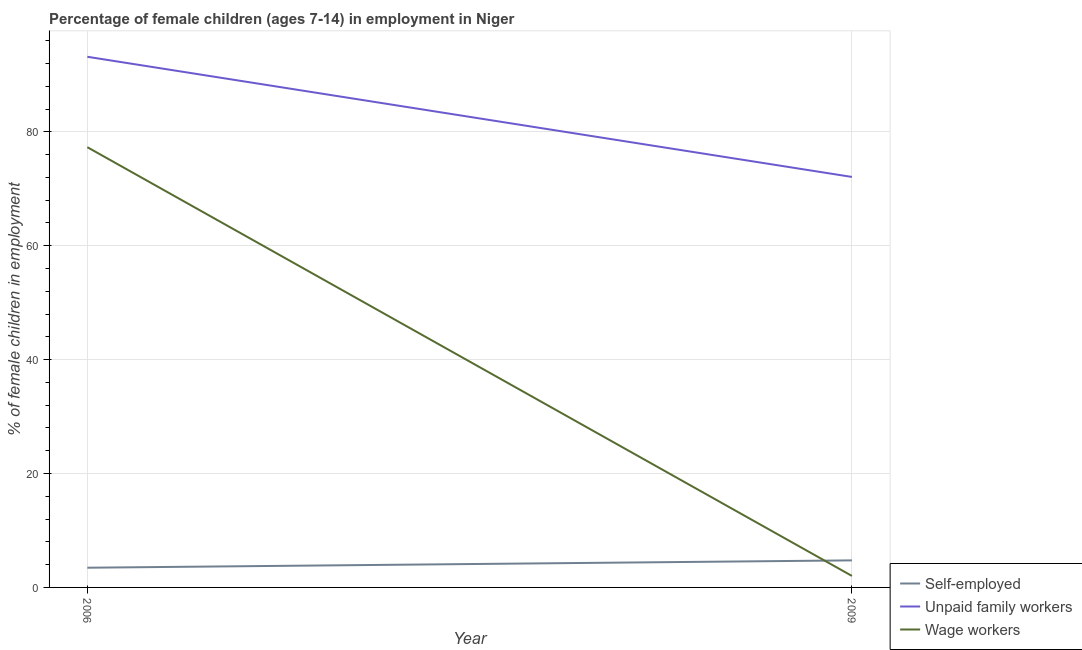What is the percentage of children employed as wage workers in 2006?
Offer a very short reply. 77.3. Across all years, what is the maximum percentage of self employed children?
Your answer should be very brief. 4.75. Across all years, what is the minimum percentage of self employed children?
Offer a very short reply. 3.46. In which year was the percentage of self employed children minimum?
Give a very brief answer. 2006. What is the total percentage of children employed as wage workers in the graph?
Your answer should be compact. 79.32. What is the difference between the percentage of children employed as wage workers in 2006 and that in 2009?
Ensure brevity in your answer.  75.28. What is the difference between the percentage of children employed as unpaid family workers in 2006 and the percentage of self employed children in 2009?
Your answer should be very brief. 88.43. What is the average percentage of self employed children per year?
Offer a very short reply. 4.11. In the year 2006, what is the difference between the percentage of self employed children and percentage of children employed as unpaid family workers?
Give a very brief answer. -89.72. What is the ratio of the percentage of self employed children in 2006 to that in 2009?
Keep it short and to the point. 0.73. Is the percentage of children employed as unpaid family workers in 2006 less than that in 2009?
Offer a terse response. No. Is it the case that in every year, the sum of the percentage of self employed children and percentage of children employed as unpaid family workers is greater than the percentage of children employed as wage workers?
Your response must be concise. Yes. Is the percentage of self employed children strictly greater than the percentage of children employed as unpaid family workers over the years?
Offer a terse response. No. What is the difference between two consecutive major ticks on the Y-axis?
Offer a terse response. 20. Are the values on the major ticks of Y-axis written in scientific E-notation?
Provide a succinct answer. No. How are the legend labels stacked?
Keep it short and to the point. Vertical. What is the title of the graph?
Give a very brief answer. Percentage of female children (ages 7-14) in employment in Niger. Does "Secondary" appear as one of the legend labels in the graph?
Give a very brief answer. No. What is the label or title of the Y-axis?
Your response must be concise. % of female children in employment. What is the % of female children in employment in Self-employed in 2006?
Keep it short and to the point. 3.46. What is the % of female children in employment in Unpaid family workers in 2006?
Give a very brief answer. 93.18. What is the % of female children in employment in Wage workers in 2006?
Provide a short and direct response. 77.3. What is the % of female children in employment of Self-employed in 2009?
Your answer should be compact. 4.75. What is the % of female children in employment in Unpaid family workers in 2009?
Make the answer very short. 72.08. What is the % of female children in employment in Wage workers in 2009?
Make the answer very short. 2.02. Across all years, what is the maximum % of female children in employment of Self-employed?
Your response must be concise. 4.75. Across all years, what is the maximum % of female children in employment in Unpaid family workers?
Offer a very short reply. 93.18. Across all years, what is the maximum % of female children in employment in Wage workers?
Your answer should be compact. 77.3. Across all years, what is the minimum % of female children in employment of Self-employed?
Give a very brief answer. 3.46. Across all years, what is the minimum % of female children in employment of Unpaid family workers?
Offer a very short reply. 72.08. Across all years, what is the minimum % of female children in employment of Wage workers?
Give a very brief answer. 2.02. What is the total % of female children in employment in Self-employed in the graph?
Your answer should be very brief. 8.21. What is the total % of female children in employment in Unpaid family workers in the graph?
Give a very brief answer. 165.26. What is the total % of female children in employment in Wage workers in the graph?
Provide a succinct answer. 79.32. What is the difference between the % of female children in employment of Self-employed in 2006 and that in 2009?
Provide a short and direct response. -1.29. What is the difference between the % of female children in employment of Unpaid family workers in 2006 and that in 2009?
Provide a succinct answer. 21.1. What is the difference between the % of female children in employment of Wage workers in 2006 and that in 2009?
Your answer should be very brief. 75.28. What is the difference between the % of female children in employment in Self-employed in 2006 and the % of female children in employment in Unpaid family workers in 2009?
Your response must be concise. -68.62. What is the difference between the % of female children in employment in Self-employed in 2006 and the % of female children in employment in Wage workers in 2009?
Your response must be concise. 1.44. What is the difference between the % of female children in employment in Unpaid family workers in 2006 and the % of female children in employment in Wage workers in 2009?
Your response must be concise. 91.16. What is the average % of female children in employment in Self-employed per year?
Your answer should be compact. 4.11. What is the average % of female children in employment of Unpaid family workers per year?
Your answer should be compact. 82.63. What is the average % of female children in employment in Wage workers per year?
Keep it short and to the point. 39.66. In the year 2006, what is the difference between the % of female children in employment in Self-employed and % of female children in employment in Unpaid family workers?
Offer a terse response. -89.72. In the year 2006, what is the difference between the % of female children in employment of Self-employed and % of female children in employment of Wage workers?
Give a very brief answer. -73.84. In the year 2006, what is the difference between the % of female children in employment of Unpaid family workers and % of female children in employment of Wage workers?
Make the answer very short. 15.88. In the year 2009, what is the difference between the % of female children in employment in Self-employed and % of female children in employment in Unpaid family workers?
Offer a terse response. -67.33. In the year 2009, what is the difference between the % of female children in employment of Self-employed and % of female children in employment of Wage workers?
Your response must be concise. 2.73. In the year 2009, what is the difference between the % of female children in employment in Unpaid family workers and % of female children in employment in Wage workers?
Provide a short and direct response. 70.06. What is the ratio of the % of female children in employment in Self-employed in 2006 to that in 2009?
Offer a very short reply. 0.73. What is the ratio of the % of female children in employment in Unpaid family workers in 2006 to that in 2009?
Ensure brevity in your answer.  1.29. What is the ratio of the % of female children in employment of Wage workers in 2006 to that in 2009?
Ensure brevity in your answer.  38.27. What is the difference between the highest and the second highest % of female children in employment in Self-employed?
Ensure brevity in your answer.  1.29. What is the difference between the highest and the second highest % of female children in employment in Unpaid family workers?
Make the answer very short. 21.1. What is the difference between the highest and the second highest % of female children in employment of Wage workers?
Provide a succinct answer. 75.28. What is the difference between the highest and the lowest % of female children in employment of Self-employed?
Your answer should be very brief. 1.29. What is the difference between the highest and the lowest % of female children in employment of Unpaid family workers?
Make the answer very short. 21.1. What is the difference between the highest and the lowest % of female children in employment in Wage workers?
Your answer should be compact. 75.28. 